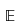<formula> <loc_0><loc_0><loc_500><loc_500>\mathbb { E }</formula> 